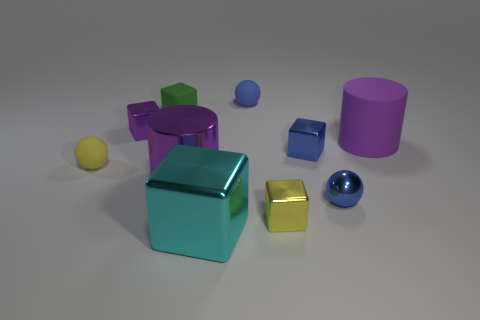Is the big metal cylinder the same color as the large matte cylinder?
Ensure brevity in your answer.  Yes. Are there fewer small blue metallic blocks that are on the right side of the large purple matte cylinder than small blue matte spheres?
Make the answer very short. Yes. Do the blue matte sphere and the purple metal cylinder have the same size?
Make the answer very short. No. What is the size of the purple cube that is made of the same material as the cyan block?
Give a very brief answer. Small. How many matte cylinders have the same color as the shiny cylinder?
Your response must be concise. 1. Are there fewer green objects to the left of the cyan block than shiny blocks to the left of the large purple rubber object?
Your response must be concise. Yes. Do the purple shiny thing that is to the right of the green matte object and the blue matte thing have the same shape?
Your answer should be very brief. No. Is the material of the small yellow thing that is on the left side of the large shiny cylinder the same as the small green block?
Your response must be concise. Yes. The tiny block that is in front of the blue metal block that is in front of the tiny matte sphere that is to the right of the green rubber cube is made of what material?
Give a very brief answer. Metal. What number of other things are the same shape as the yellow shiny object?
Give a very brief answer. 4. 